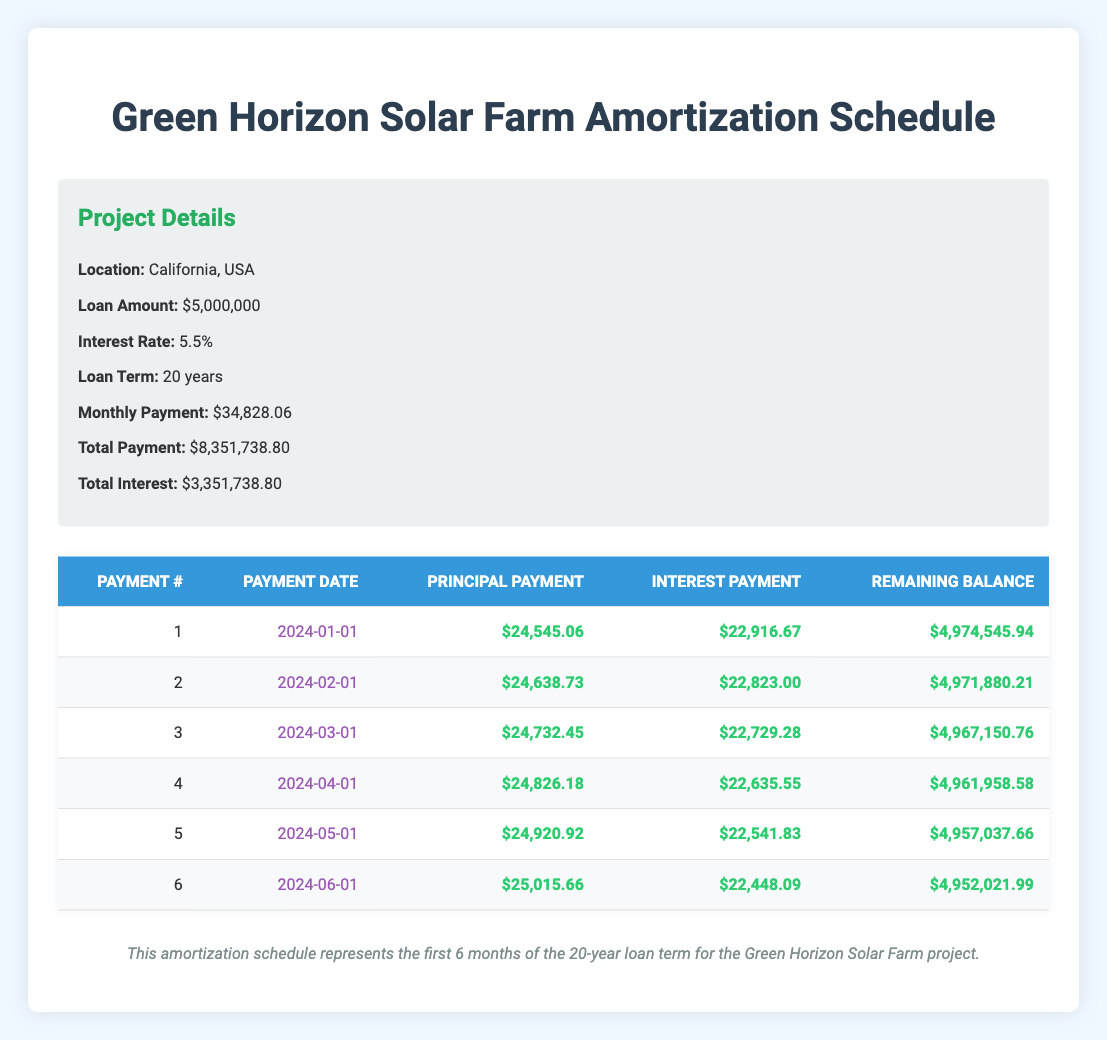What is the monthly payment for the Green Horizon Solar Farm project? The monthly payment is provided in the project details section of the table, showing a value of $34,828.06.
Answer: $34,828.06 How much for the principal payment is made in the first month? The principal payment for the first month is indicated in the first row of the amortization schedule, which states $24,545.06.
Answer: $24,545.06 What is the total principal paid after the first six months? To find the total principal paid, sum the principal payments for the first six months: $24,545.06 + $24,638.73 + $24,732.45 + $24,826.18 + $24,920.92 + $25,015.66 = $148,878.00.
Answer: $148,878.00 Is the interest payment for the third month higher than for the second month? The interest payment for the third month is $22,729.28, and for the second month, it is $22,823.00. Since $22,729.28 < $22,823.00, the interest payment for the third month is not higher than for the second month.
Answer: No What is the remaining balance after the fifth payment? The remaining balance is listed in the fifth row of the table as $4,957,037.66.
Answer: $4,957,037.66 What is the average principal payment for the first six months? To find the average principal payment, sum the principal payments over the six months: ($24,545.06 + $24,638.73 + $24,732.45 + $24,826.18 + $24,920.92 + $25,015.66 = $148,878.00) and divide by 6, resulting in an average of $24,813.00.
Answer: $24,813.00 How much total interest is paid in the first three months? To find the total interest paid in the first three months, sum the interest payments: $22,916.67 + $22,823.00 + $22,729.28 = $68,469.95.
Answer: $68,469.95 Do the remaining balance decrease steadily with each payment? Analyzing the remaining balances shows that they decrease from $4,974,545.94 to $4,952,021.99, which is a steady decrease. Since the balance decreases every month, the answer is yes.
Answer: Yes What is the difference between the monthly payment and the interest payment in the sixth month? The monthly payment is $34,828.06, and the interest payment in the sixth month is $22,448.09; calculating the difference gives $34,828.06 - $22,448.09 = $12,379.97.
Answer: $12,379.97 